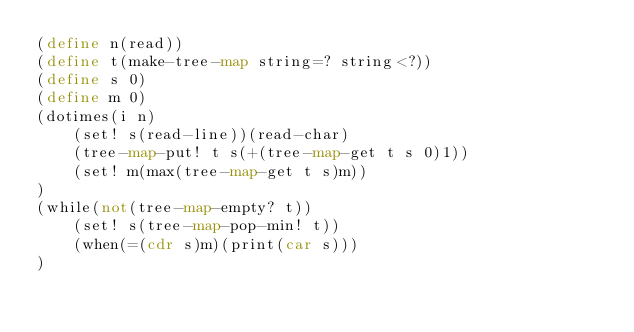<code> <loc_0><loc_0><loc_500><loc_500><_Scheme_>(define n(read))
(define t(make-tree-map string=? string<?))
(define s 0)
(define m 0)
(dotimes(i n)
	(set! s(read-line))(read-char)
	(tree-map-put! t s(+(tree-map-get t s 0)1))
	(set! m(max(tree-map-get t s)m))
)
(while(not(tree-map-empty? t))
	(set! s(tree-map-pop-min! t))
	(when(=(cdr s)m)(print(car s)))
)</code> 